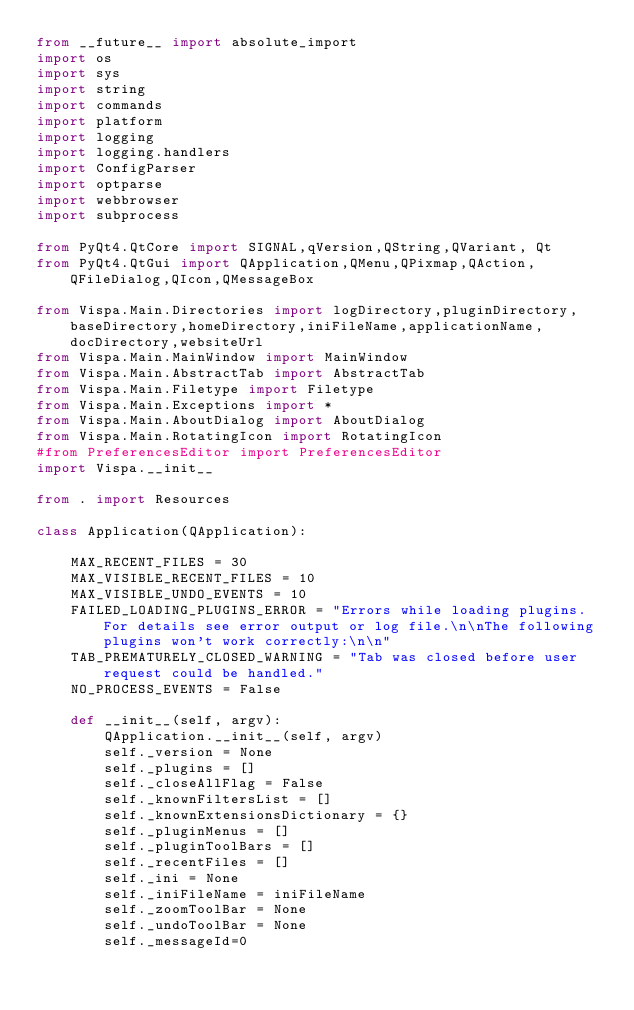<code> <loc_0><loc_0><loc_500><loc_500><_Python_>from __future__ import absolute_import
import os
import sys
import string
import commands
import platform
import logging
import logging.handlers
import ConfigParser
import optparse
import webbrowser
import subprocess

from PyQt4.QtCore import SIGNAL,qVersion,QString,QVariant, Qt
from PyQt4.QtGui import QApplication,QMenu,QPixmap,QAction,QFileDialog,QIcon,QMessageBox

from Vispa.Main.Directories import logDirectory,pluginDirectory,baseDirectory,homeDirectory,iniFileName,applicationName,docDirectory,websiteUrl
from Vispa.Main.MainWindow import MainWindow
from Vispa.Main.AbstractTab import AbstractTab
from Vispa.Main.Filetype import Filetype
from Vispa.Main.Exceptions import *
from Vispa.Main.AboutDialog import AboutDialog
from Vispa.Main.RotatingIcon import RotatingIcon 
#from PreferencesEditor import PreferencesEditor
import Vispa.__init__

from . import Resources

class Application(QApplication):

    MAX_RECENT_FILES = 30
    MAX_VISIBLE_RECENT_FILES = 10
    MAX_VISIBLE_UNDO_EVENTS = 10
    FAILED_LOADING_PLUGINS_ERROR = "Errors while loading plugins. For details see error output or log file.\n\nThe following plugins won't work correctly:\n\n"
    TAB_PREMATURELY_CLOSED_WARNING = "Tab was closed before user request could be handled."
    NO_PROCESS_EVENTS = False

    def __init__(self, argv):
        QApplication.__init__(self, argv)
        self._version = None
        self._plugins = []
        self._closeAllFlag = False
        self._knownFiltersList = []
        self._knownExtensionsDictionary = {}
        self._pluginMenus = []
        self._pluginToolBars = []
        self._recentFiles = []
        self._ini = None
        self._iniFileName = iniFileName
        self._zoomToolBar = None
        self._undoToolBar = None
        self._messageId=0</code> 